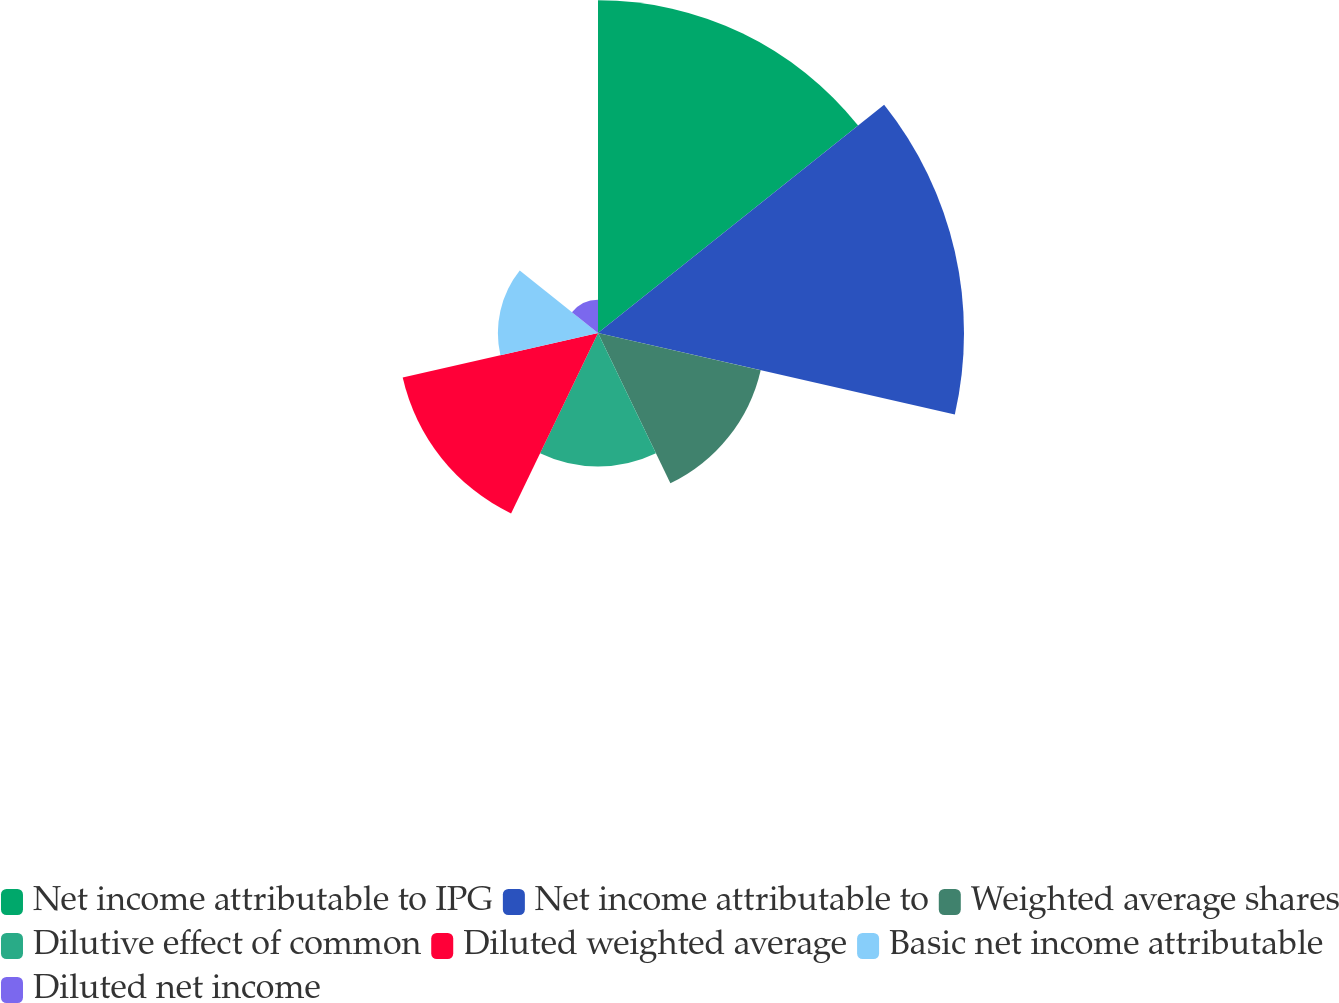<chart> <loc_0><loc_0><loc_500><loc_500><pie_chart><fcel>Net income attributable to IPG<fcel>Net income attributable to<fcel>Weighted average shares<fcel>Dilutive effect of common<fcel>Diluted weighted average<fcel>Basic net income attributable<fcel>Diluted net income<nl><fcel>24.96%<fcel>27.46%<fcel>12.52%<fcel>10.02%<fcel>15.03%<fcel>7.51%<fcel>2.5%<nl></chart> 